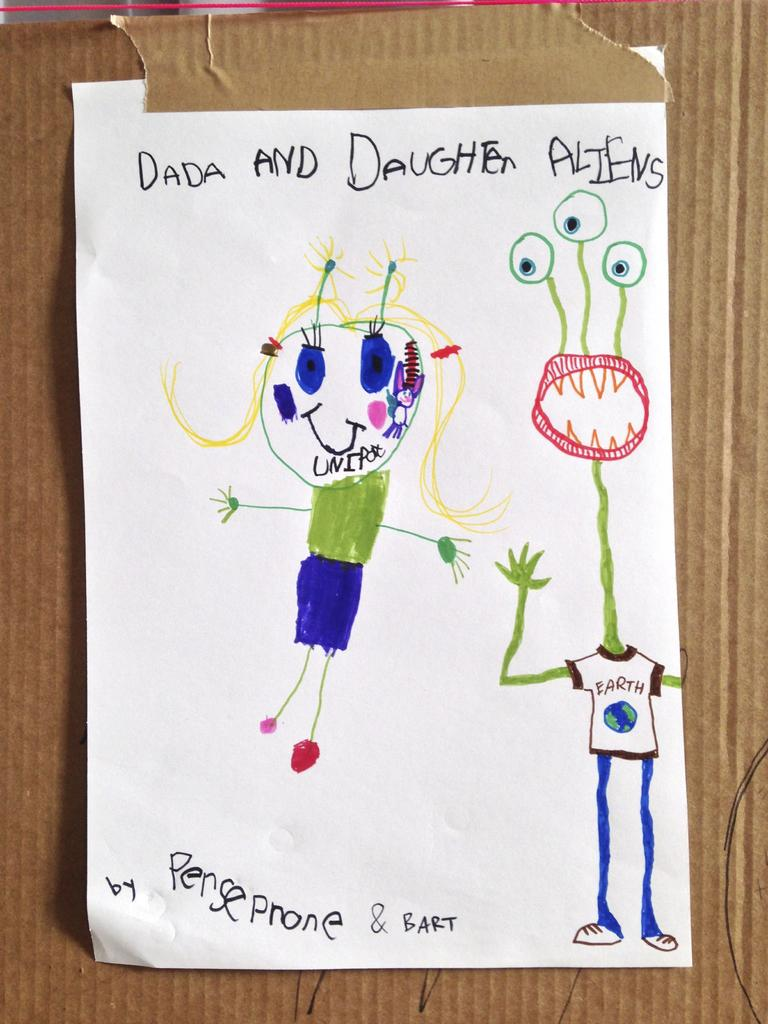What is the main object in the image? There is a cardboard in the image. What is attached to the cardboard? There is paper attached to the cardboard. What can be seen on the paper? The paper has drawings and text on it. What type of wilderness can be seen in the background of the image? There is no wilderness present in the image; it features a cardboard with paper attached to it. How does the death of the artist affect the drawings on the paper? There is no information about the artist's death, and therefore it cannot be determined how it would affect the drawings on the paper. 